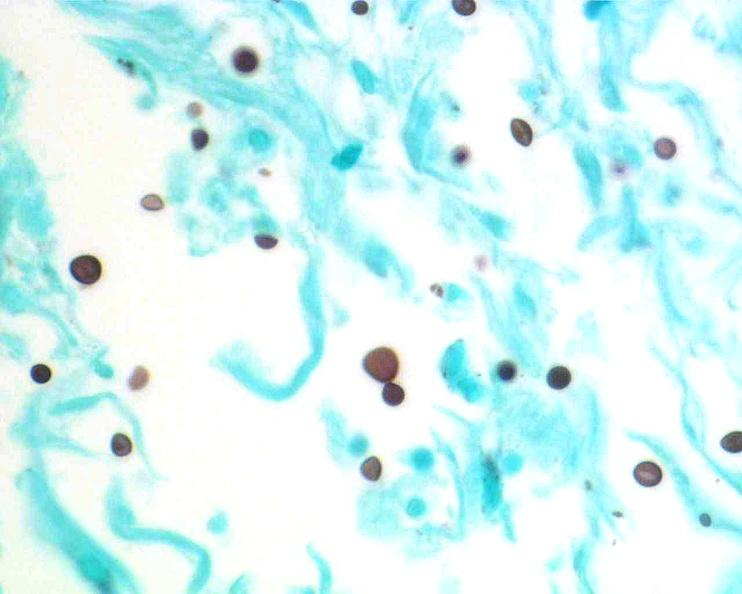where is this?
Answer the question using a single word or phrase. Nervous 